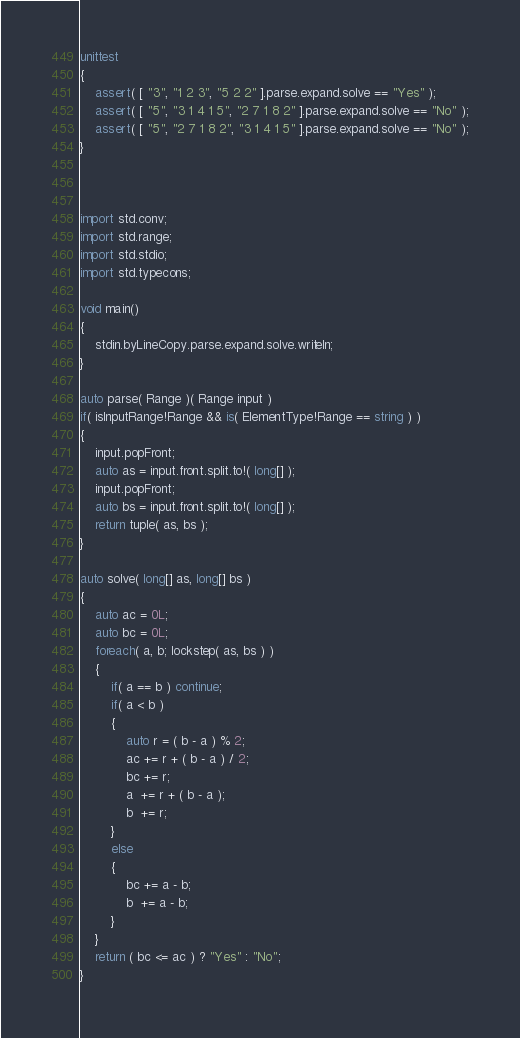<code> <loc_0><loc_0><loc_500><loc_500><_D_>unittest
{
	assert( [ "3", "1 2 3", "5 2 2" ].parse.expand.solve == "Yes" );
	assert( [ "5", "3 1 4 1 5", "2 7 1 8 2" ].parse.expand.solve == "No" );
	assert( [ "5", "2 7 1 8 2", "3 1 4 1 5" ].parse.expand.solve == "No" );
}



import std.conv;
import std.range;
import std.stdio;
import std.typecons;

void main()
{
	stdin.byLineCopy.parse.expand.solve.writeln;
}

auto parse( Range )( Range input )
if( isInputRange!Range && is( ElementType!Range == string ) )
{
	input.popFront;
	auto as = input.front.split.to!( long[] );
	input.popFront;
	auto bs = input.front.split.to!( long[] );
	return tuple( as, bs );
}

auto solve( long[] as, long[] bs )
{
	auto ac = 0L;
	auto bc = 0L;
	foreach( a, b; lockstep( as, bs ) )
	{
		if( a == b ) continue;
		if( a < b )
		{
			auto r = ( b - a ) % 2;
			ac += r + ( b - a ) / 2;
			bc += r;
			a  += r + ( b - a );
			b  += r;
		}
		else
		{
			bc += a - b;
			b  += a - b;
		}
	}
	return ( bc <= ac ) ? "Yes" : "No";
}
</code> 